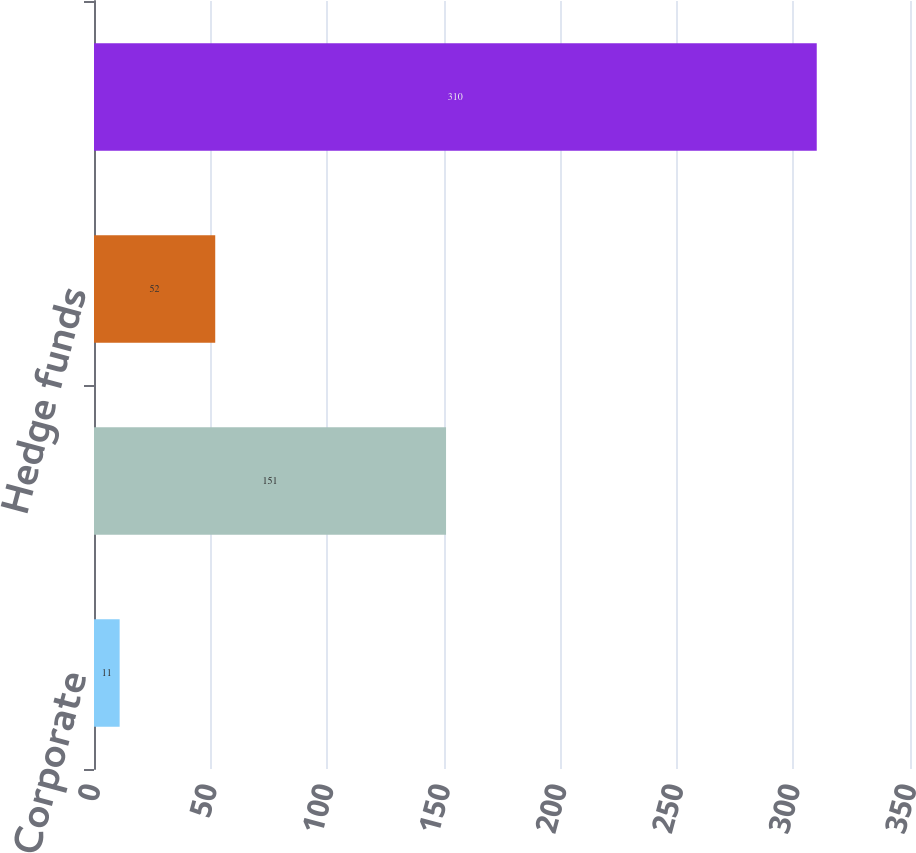<chart> <loc_0><loc_0><loc_500><loc_500><bar_chart><fcel>Corporate<fcel>Mortgage backed and asset<fcel>Hedge funds<fcel>Total<nl><fcel>11<fcel>151<fcel>52<fcel>310<nl></chart> 